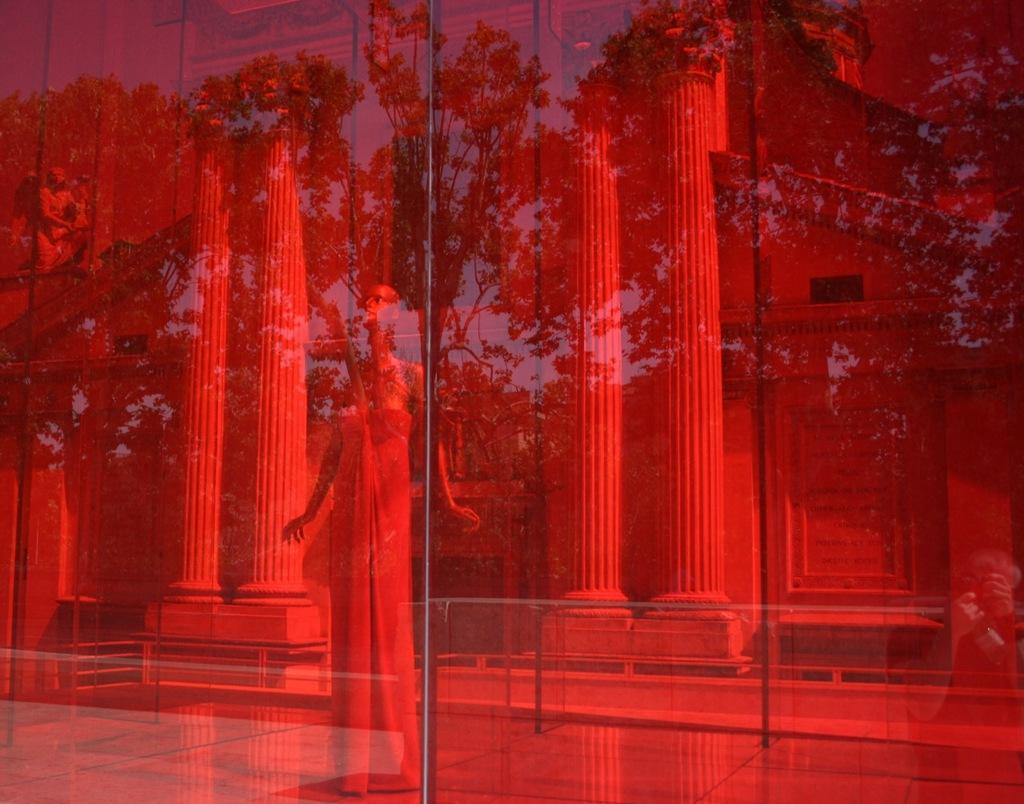What type of reflections can be seen in the image? There are reflections of statues, pillars, plants, and trees in the image. What is the color of the glass with the reflections? The glass with the reflections is red in color. How many boys are standing near the red glass in the image? There are no boys present in the image; it only shows reflections of statues, pillars, plants, and trees. What type of bushes can be seen growing near the red glass in the image? There are no bushes visible in the image; it only shows reflections of various objects. 